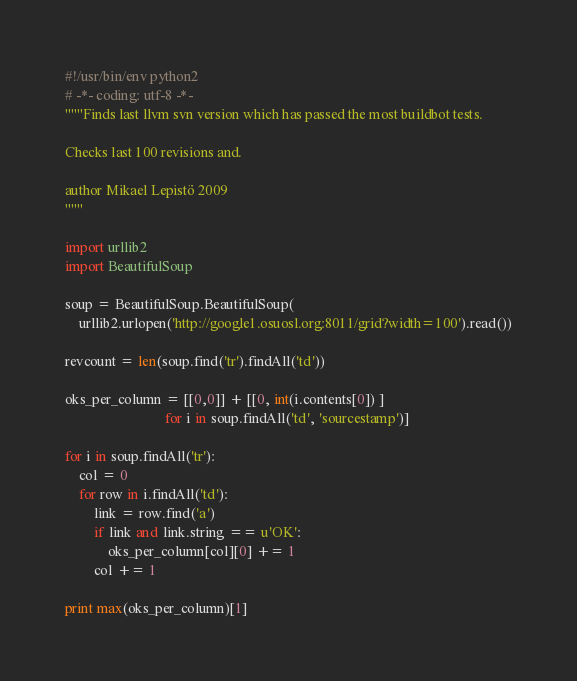<code> <loc_0><loc_0><loc_500><loc_500><_Python_>#!/usr/bin/env python2
# -*- coding: utf-8 -*-
"""Finds last llvm svn version which has passed the most buildbot tests.

Checks last 100 revisions and.

author Mikael Lepistö 2009
"""

import urllib2
import BeautifulSoup

soup = BeautifulSoup.BeautifulSoup(
    urllib2.urlopen('http://google1.osuosl.org:8011/grid?width=100').read())

revcount = len(soup.find('tr').findAll('td'))

oks_per_column = [[0,0]] + [[0, int(i.contents[0]) ]
                            for i in soup.findAll('td', 'sourcestamp')]

for i in soup.findAll('tr'):
	col = 0
	for row in i.findAll('td'):
		link = row.find('a')
		if link and link.string == u'OK':
			oks_per_column[col][0] += 1
		col += 1

print max(oks_per_column)[1]
</code> 